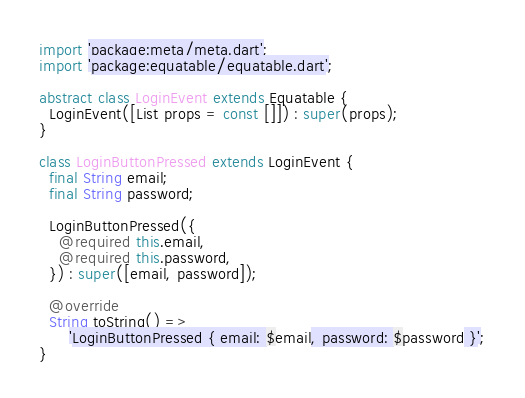<code> <loc_0><loc_0><loc_500><loc_500><_Dart_>import 'package:meta/meta.dart';
import 'package:equatable/equatable.dart';

abstract class LoginEvent extends Equatable {
  LoginEvent([List props = const []]) : super(props);
}

class LoginButtonPressed extends LoginEvent {
  final String email;
  final String password;

  LoginButtonPressed({
    @required this.email,
    @required this.password,
  }) : super([email, password]);

  @override
  String toString() =>
      'LoginButtonPressed { email: $email, password: $password }';
}

</code> 